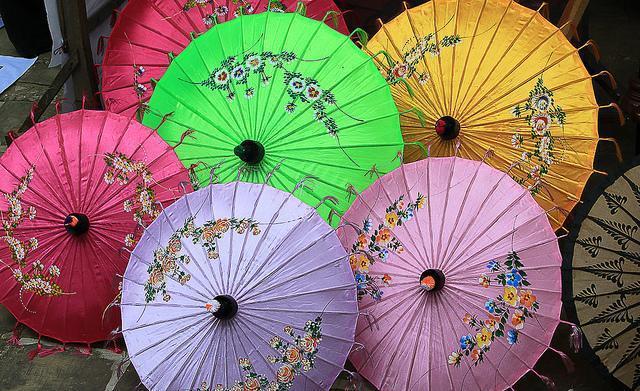How many umbrellas are shown?
Give a very brief answer. 7. How many items are in the image?
Give a very brief answer. 7. How many umbrellas are in the photo?
Give a very brief answer. 7. How many cats are in the vase?
Give a very brief answer. 0. 